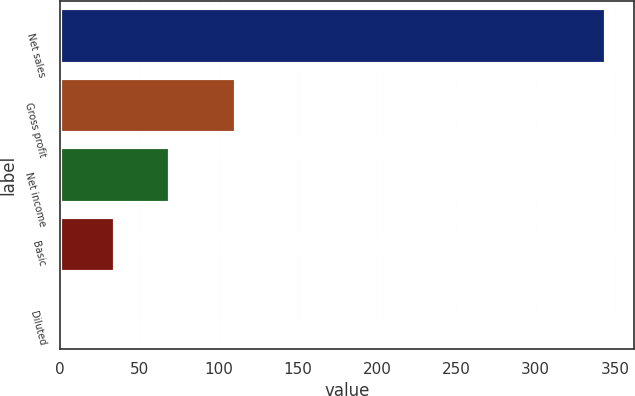Convert chart. <chart><loc_0><loc_0><loc_500><loc_500><bar_chart><fcel>Net sales<fcel>Gross profit<fcel>Net income<fcel>Basic<fcel>Diluted<nl><fcel>344.5<fcel>110.9<fcel>69.25<fcel>34.84<fcel>0.43<nl></chart> 